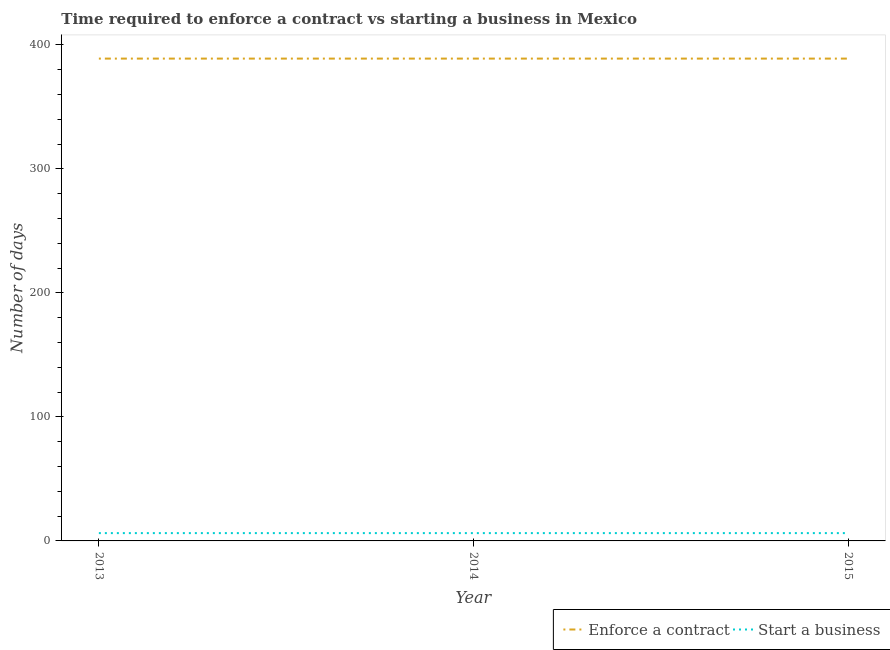Across all years, what is the minimum number of days to start a business?
Make the answer very short. 6.3. In which year was the number of days to enforece a contract maximum?
Give a very brief answer. 2013. In which year was the number of days to start a business minimum?
Your response must be concise. 2013. What is the total number of days to enforece a contract in the graph?
Give a very brief answer. 1167. What is the difference between the number of days to start a business in 2015 and the number of days to enforece a contract in 2014?
Make the answer very short. -382.7. In the year 2015, what is the difference between the number of days to start a business and number of days to enforece a contract?
Provide a short and direct response. -382.7. Is the number of days to start a business in 2013 less than that in 2014?
Your response must be concise. No. Is the difference between the number of days to enforece a contract in 2014 and 2015 greater than the difference between the number of days to start a business in 2014 and 2015?
Offer a very short reply. No. What is the difference between the highest and the second highest number of days to enforece a contract?
Ensure brevity in your answer.  0. What is the difference between the highest and the lowest number of days to enforece a contract?
Your answer should be very brief. 0. In how many years, is the number of days to start a business greater than the average number of days to start a business taken over all years?
Offer a very short reply. 0. Is the sum of the number of days to enforece a contract in 2013 and 2015 greater than the maximum number of days to start a business across all years?
Make the answer very short. Yes. Is the number of days to start a business strictly greater than the number of days to enforece a contract over the years?
Give a very brief answer. No. Is the number of days to enforece a contract strictly less than the number of days to start a business over the years?
Provide a short and direct response. No. What is the difference between two consecutive major ticks on the Y-axis?
Ensure brevity in your answer.  100. Are the values on the major ticks of Y-axis written in scientific E-notation?
Your response must be concise. No. Where does the legend appear in the graph?
Offer a very short reply. Bottom right. How are the legend labels stacked?
Your answer should be compact. Horizontal. What is the title of the graph?
Offer a very short reply. Time required to enforce a contract vs starting a business in Mexico. What is the label or title of the Y-axis?
Offer a terse response. Number of days. What is the Number of days in Enforce a contract in 2013?
Your response must be concise. 389. What is the Number of days in Enforce a contract in 2014?
Make the answer very short. 389. What is the Number of days in Enforce a contract in 2015?
Offer a very short reply. 389. What is the Number of days in Start a business in 2015?
Offer a terse response. 6.3. Across all years, what is the maximum Number of days of Enforce a contract?
Ensure brevity in your answer.  389. Across all years, what is the minimum Number of days in Enforce a contract?
Provide a short and direct response. 389. Across all years, what is the minimum Number of days of Start a business?
Your response must be concise. 6.3. What is the total Number of days of Enforce a contract in the graph?
Offer a very short reply. 1167. What is the difference between the Number of days in Enforce a contract in 2013 and that in 2014?
Make the answer very short. 0. What is the difference between the Number of days of Start a business in 2014 and that in 2015?
Keep it short and to the point. 0. What is the difference between the Number of days in Enforce a contract in 2013 and the Number of days in Start a business in 2014?
Keep it short and to the point. 382.7. What is the difference between the Number of days of Enforce a contract in 2013 and the Number of days of Start a business in 2015?
Ensure brevity in your answer.  382.7. What is the difference between the Number of days of Enforce a contract in 2014 and the Number of days of Start a business in 2015?
Your answer should be compact. 382.7. What is the average Number of days of Enforce a contract per year?
Your answer should be very brief. 389. In the year 2013, what is the difference between the Number of days of Enforce a contract and Number of days of Start a business?
Keep it short and to the point. 382.7. In the year 2014, what is the difference between the Number of days in Enforce a contract and Number of days in Start a business?
Your answer should be very brief. 382.7. In the year 2015, what is the difference between the Number of days in Enforce a contract and Number of days in Start a business?
Give a very brief answer. 382.7. What is the ratio of the Number of days in Enforce a contract in 2013 to that in 2014?
Your response must be concise. 1. What is the ratio of the Number of days in Start a business in 2013 to that in 2014?
Offer a terse response. 1. What is the ratio of the Number of days in Enforce a contract in 2014 to that in 2015?
Your answer should be very brief. 1. What is the ratio of the Number of days in Start a business in 2014 to that in 2015?
Provide a succinct answer. 1. What is the difference between the highest and the lowest Number of days of Start a business?
Make the answer very short. 0. 